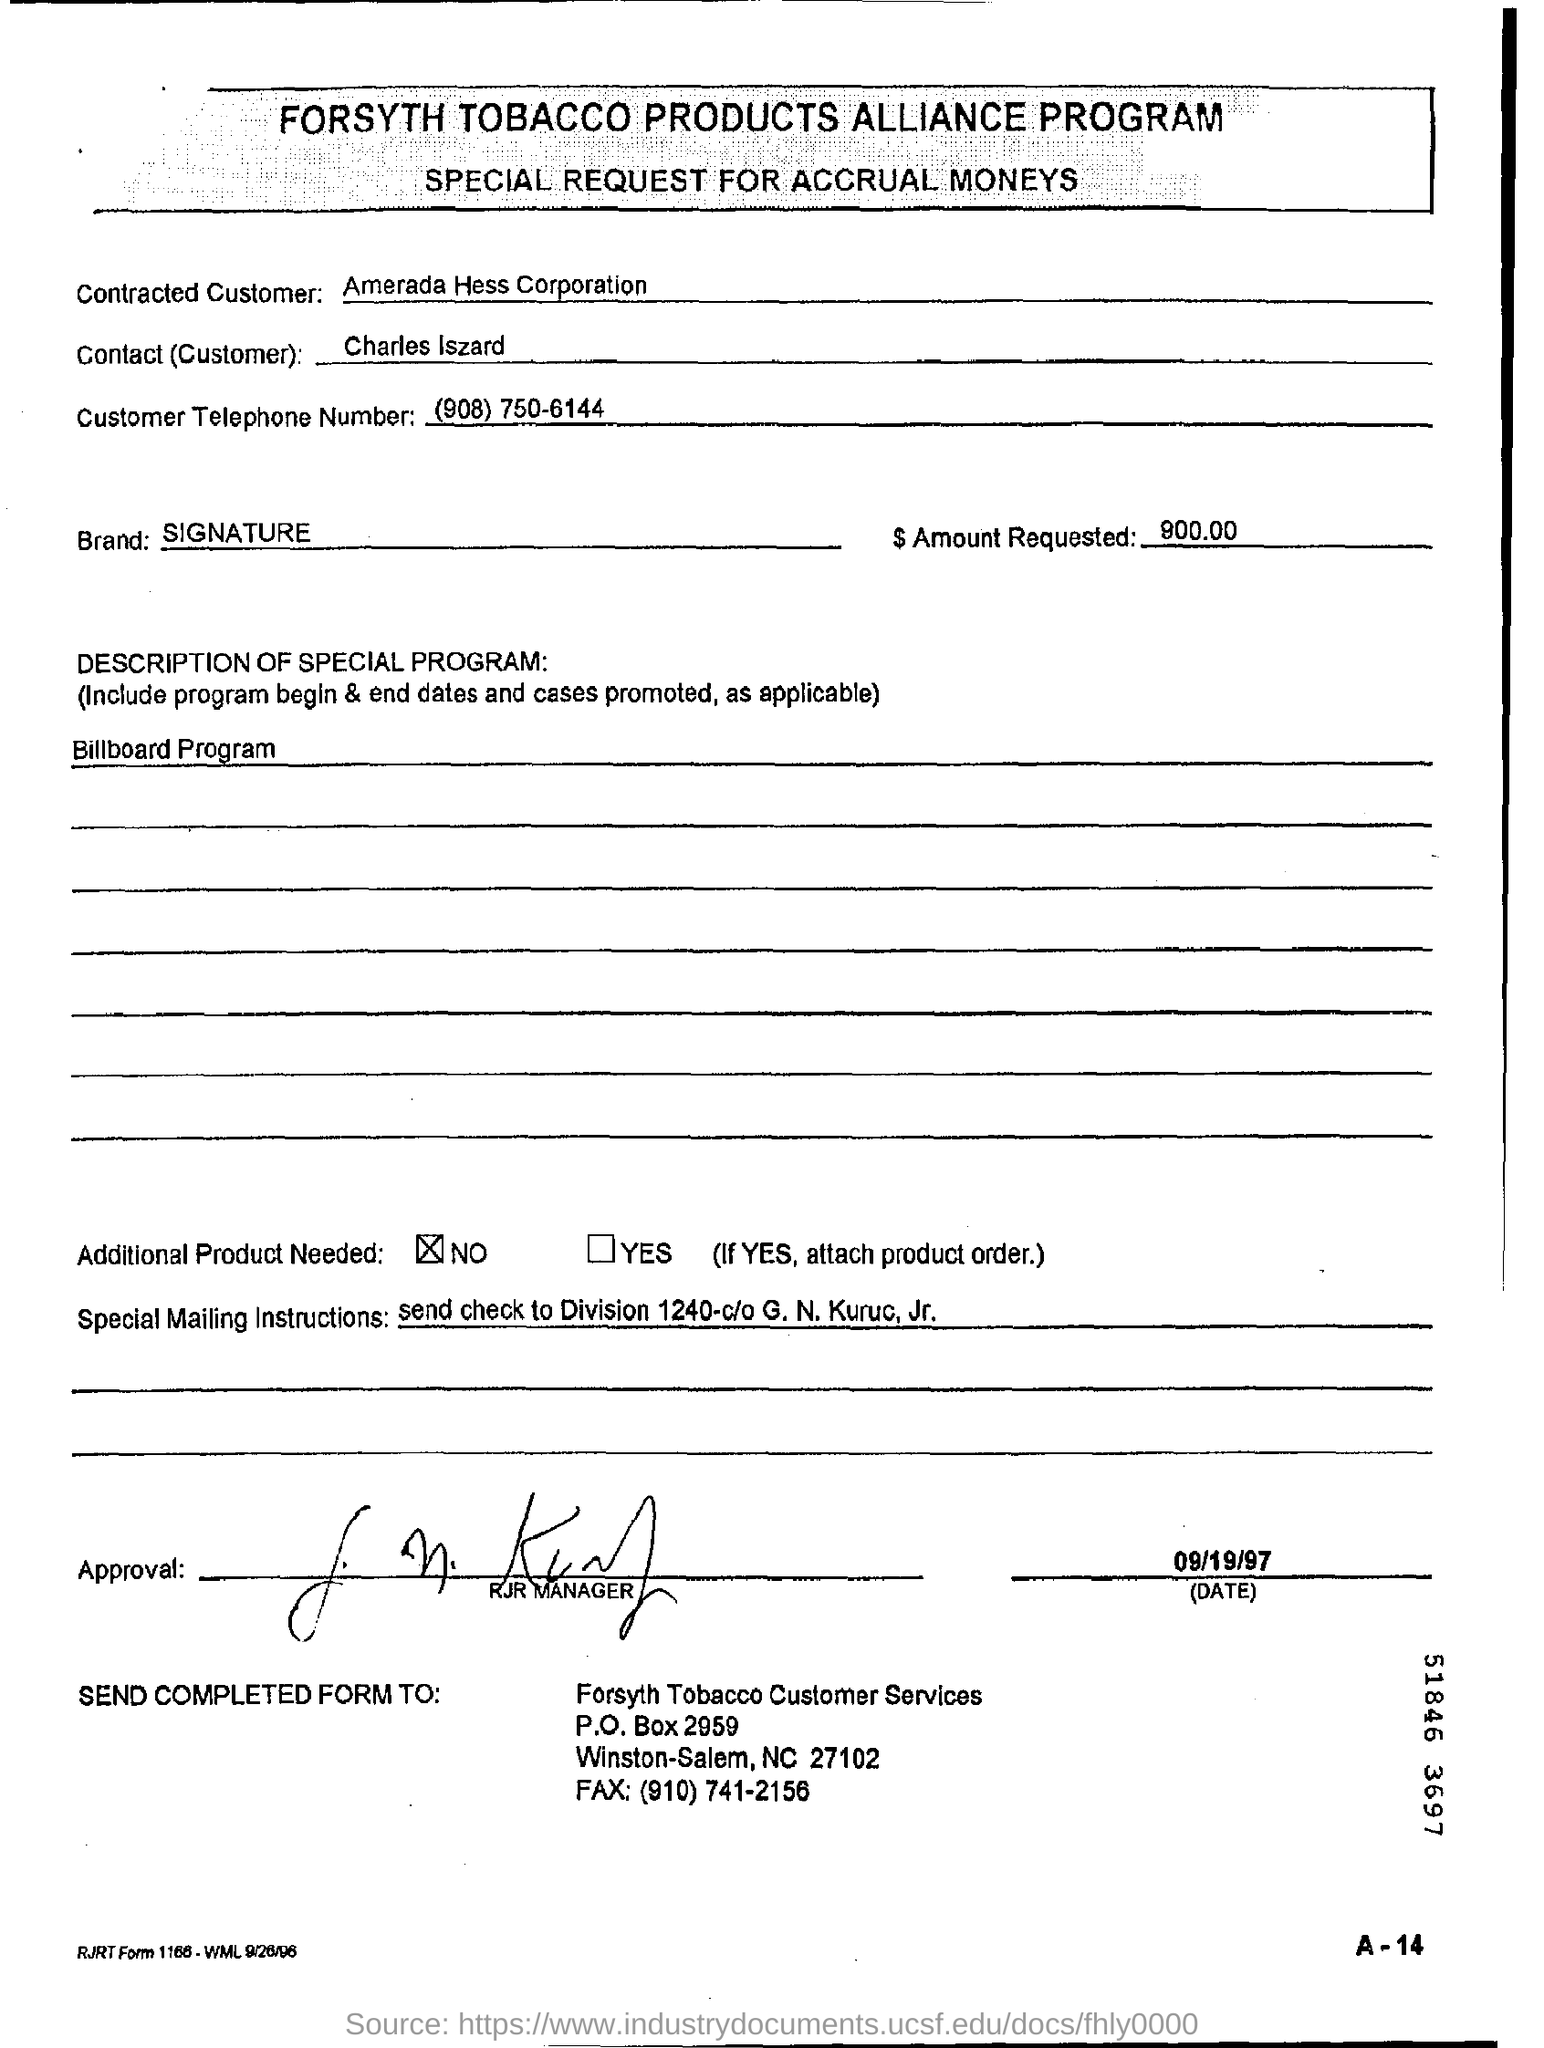What is the special request for?
Your answer should be very brief. Accrual moneys. Who is the contracted customer?
Give a very brief answer. Amerada hess corporation. What is customer telephone number?
Your response must be concise. (908) 750-6144. Who is the contact (customer)?
Provide a succinct answer. Charles iszard. Which brand is mentioned in the form?
Provide a short and direct response. Signature. What is the description of special program?
Keep it short and to the point. Billboard program. Is additional product needed?
Keep it short and to the point. No. What are the special mailing instructions?
Offer a terse response. Send check to Division 1240-c/o G. N. Kuruc, Jr. To whom should the completed form be sent?
Keep it short and to the point. Forsyth Tobacco Customer Services. What is the date on the form?
Your response must be concise. 09/19/97. 